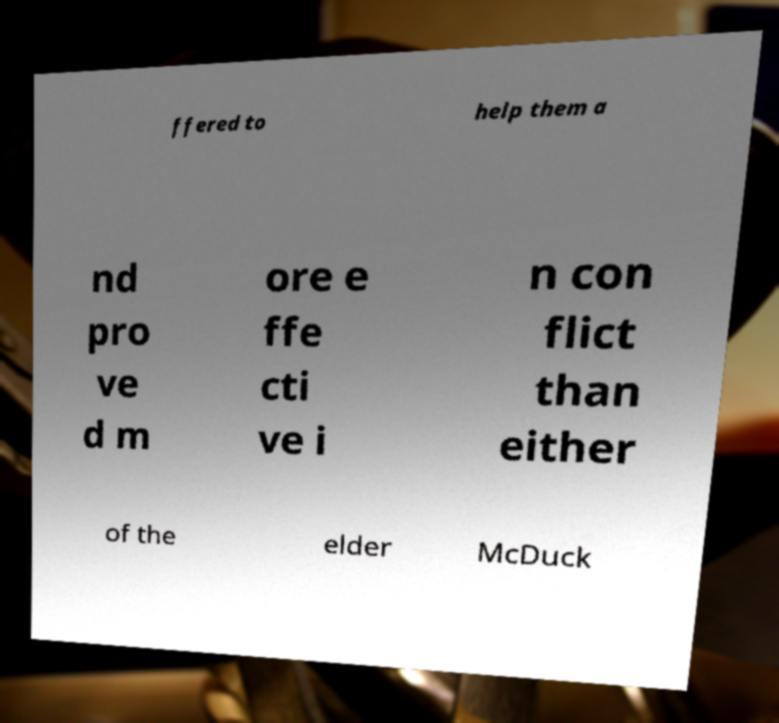For documentation purposes, I need the text within this image transcribed. Could you provide that? ffered to help them a nd pro ve d m ore e ffe cti ve i n con flict than either of the elder McDuck 